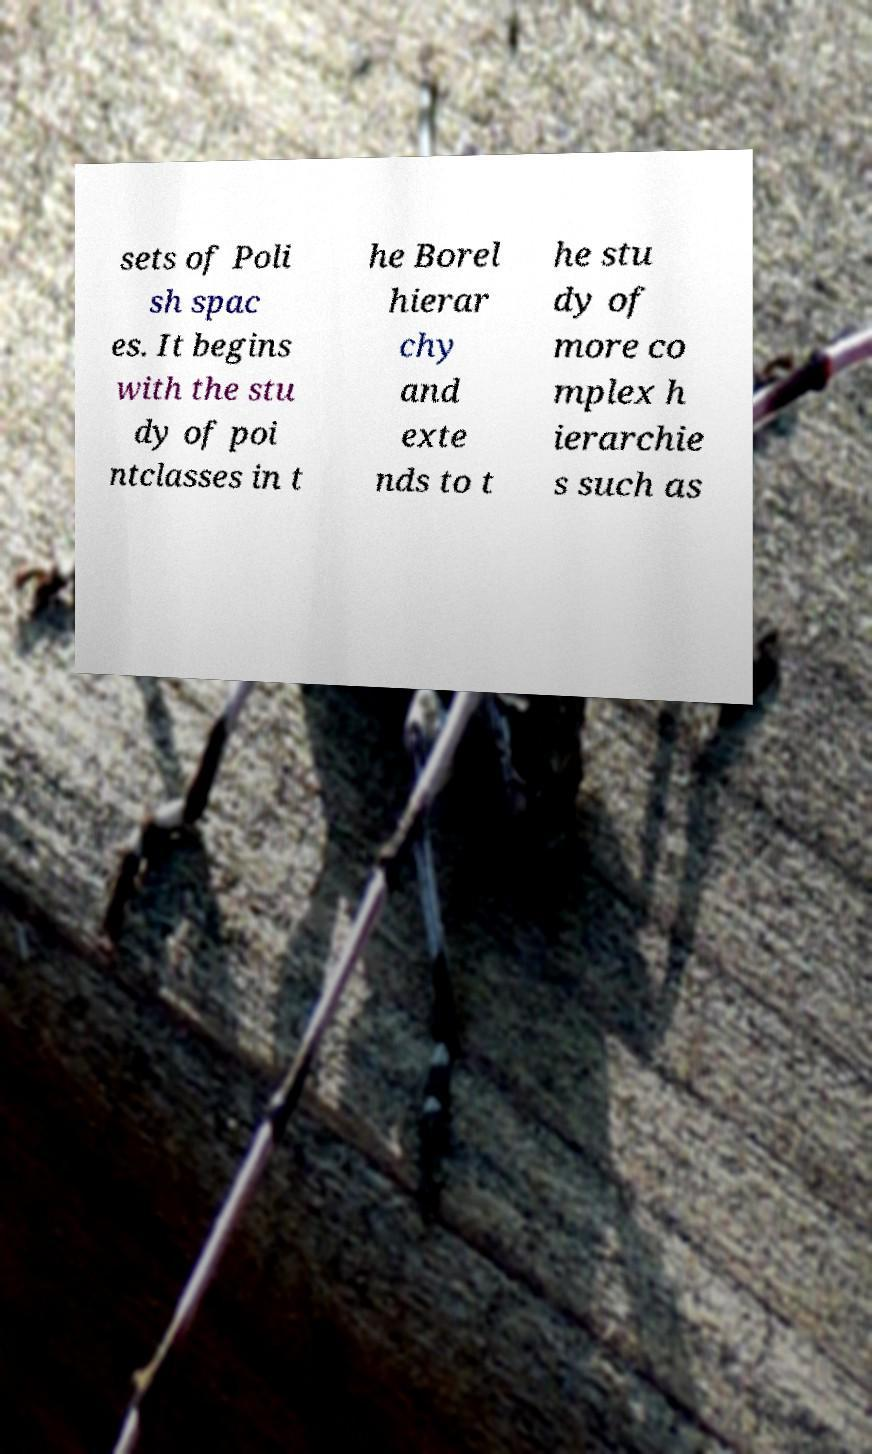Can you read and provide the text displayed in the image?This photo seems to have some interesting text. Can you extract and type it out for me? sets of Poli sh spac es. It begins with the stu dy of poi ntclasses in t he Borel hierar chy and exte nds to t he stu dy of more co mplex h ierarchie s such as 